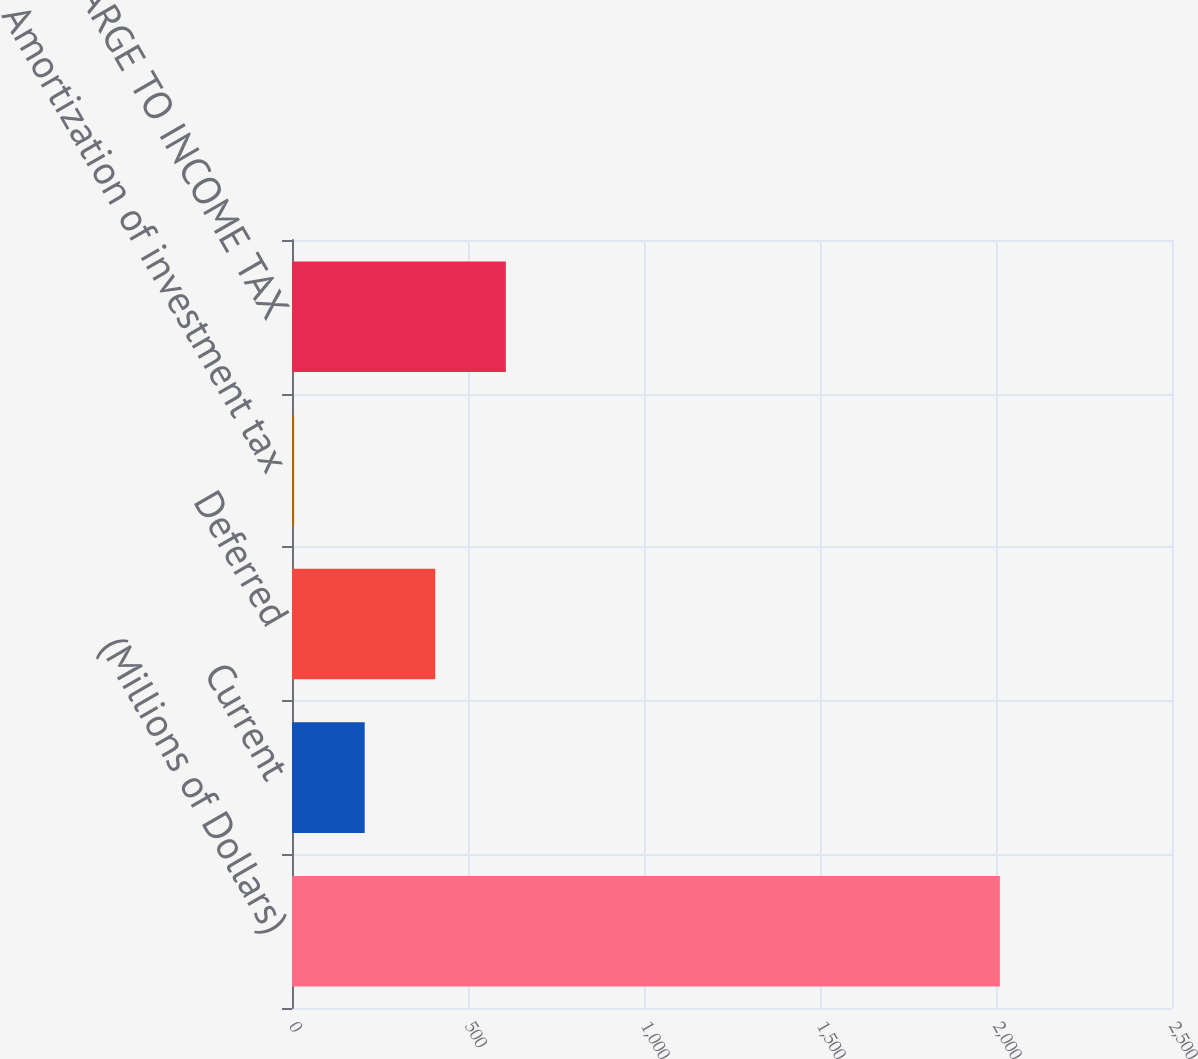Convert chart to OTSL. <chart><loc_0><loc_0><loc_500><loc_500><bar_chart><fcel>(Millions of Dollars)<fcel>Current<fcel>Deferred<fcel>Amortization of investment tax<fcel>TOTAL CHARGE TO INCOME TAX<nl><fcel>2011<fcel>206.5<fcel>407<fcel>6<fcel>607.5<nl></chart> 